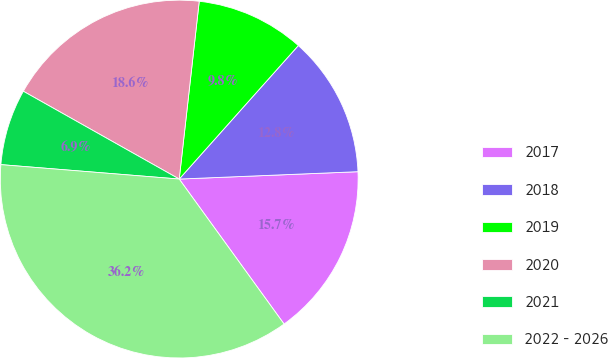Convert chart. <chart><loc_0><loc_0><loc_500><loc_500><pie_chart><fcel>2017<fcel>2018<fcel>2019<fcel>2020<fcel>2021<fcel>2022 - 2026<nl><fcel>15.69%<fcel>12.75%<fcel>9.81%<fcel>18.62%<fcel>6.88%<fcel>36.25%<nl></chart> 